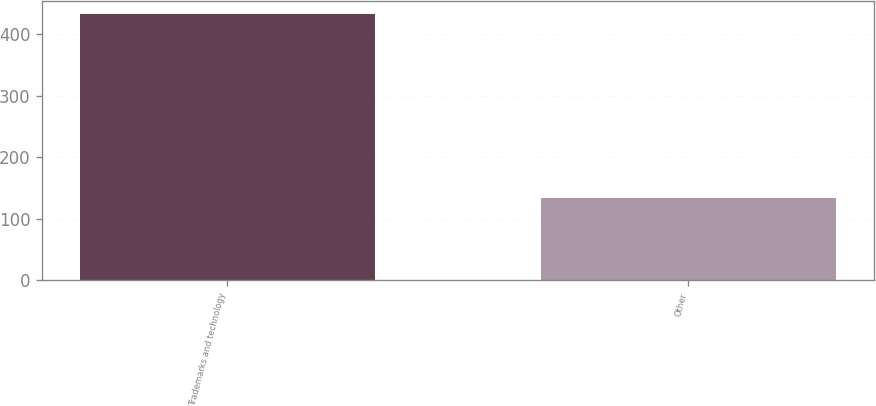Convert chart to OTSL. <chart><loc_0><loc_0><loc_500><loc_500><bar_chart><fcel>Trademarks and technology<fcel>Other<nl><fcel>432<fcel>134<nl></chart> 